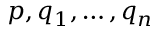<formula> <loc_0><loc_0><loc_500><loc_500>p , q _ { 1 } , \dots , q _ { n }</formula> 